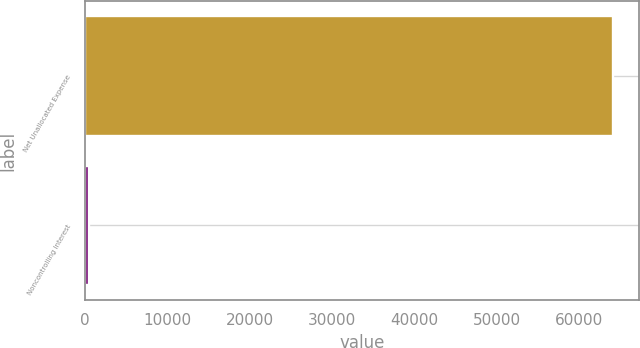Convert chart. <chart><loc_0><loc_0><loc_500><loc_500><bar_chart><fcel>Net Unallocated Expense<fcel>Noncontrolling Interest<nl><fcel>64171<fcel>442<nl></chart> 